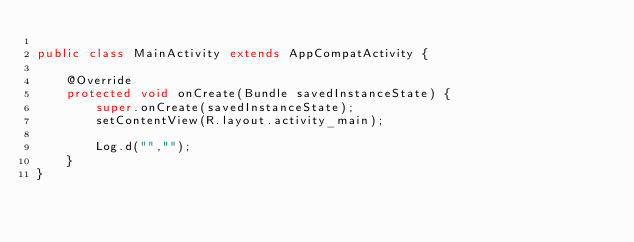<code> <loc_0><loc_0><loc_500><loc_500><_Java_>
public class MainActivity extends AppCompatActivity {

    @Override
    protected void onCreate(Bundle savedInstanceState) {
        super.onCreate(savedInstanceState);
        setContentView(R.layout.activity_main);

        Log.d("","");
    }
}</code> 